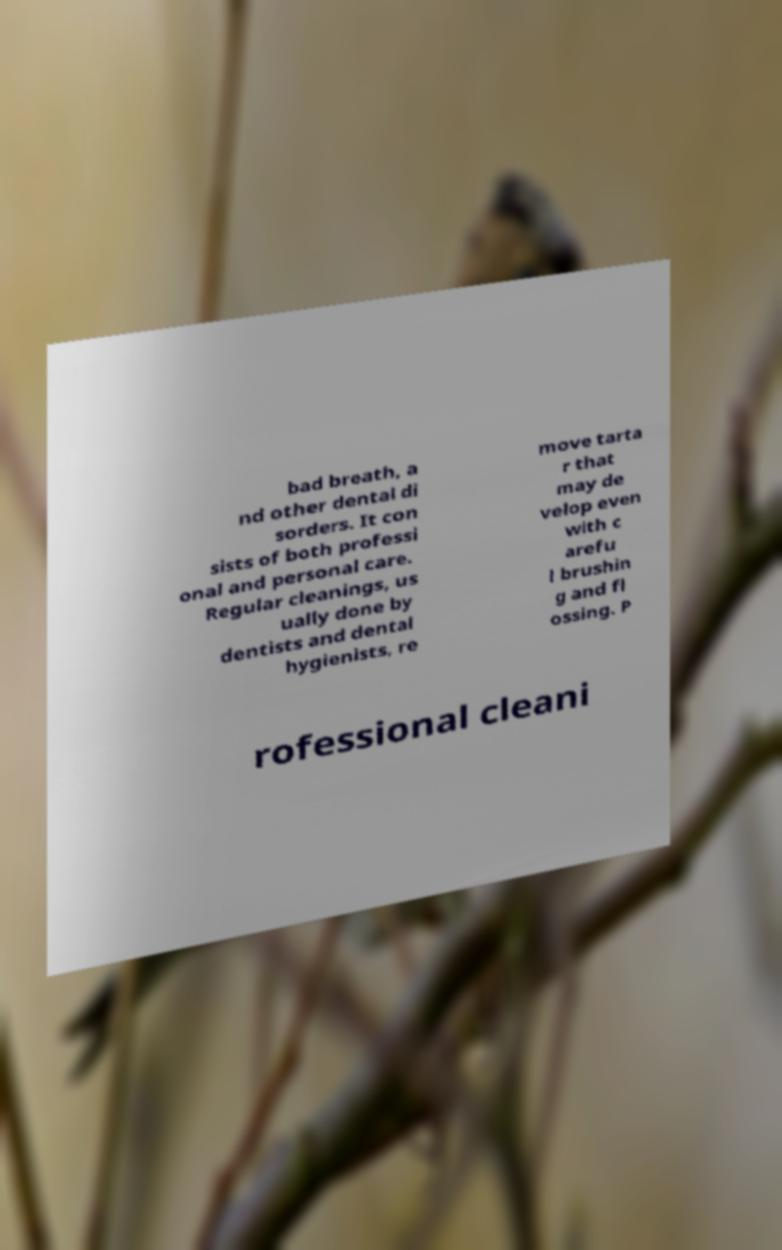Can you accurately transcribe the text from the provided image for me? bad breath, a nd other dental di sorders. It con sists of both professi onal and personal care. Regular cleanings, us ually done by dentists and dental hygienists, re move tarta r that may de velop even with c arefu l brushin g and fl ossing. P rofessional cleani 